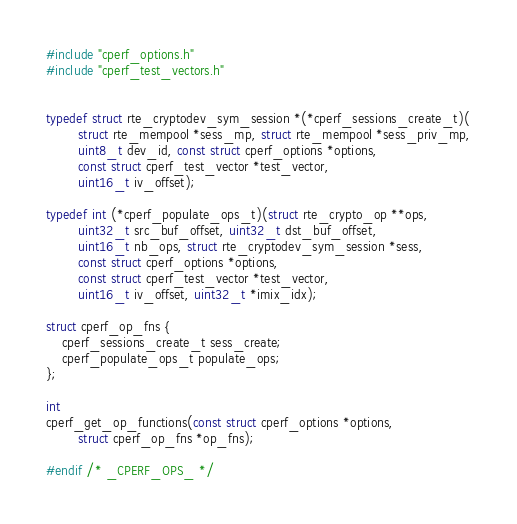<code> <loc_0><loc_0><loc_500><loc_500><_C_>#include "cperf_options.h"
#include "cperf_test_vectors.h"


typedef struct rte_cryptodev_sym_session *(*cperf_sessions_create_t)(
		struct rte_mempool *sess_mp, struct rte_mempool *sess_priv_mp,
		uint8_t dev_id, const struct cperf_options *options,
		const struct cperf_test_vector *test_vector,
		uint16_t iv_offset);

typedef int (*cperf_populate_ops_t)(struct rte_crypto_op **ops,
		uint32_t src_buf_offset, uint32_t dst_buf_offset,
		uint16_t nb_ops, struct rte_cryptodev_sym_session *sess,
		const struct cperf_options *options,
		const struct cperf_test_vector *test_vector,
		uint16_t iv_offset, uint32_t *imix_idx);

struct cperf_op_fns {
	cperf_sessions_create_t sess_create;
	cperf_populate_ops_t populate_ops;
};

int
cperf_get_op_functions(const struct cperf_options *options,
		struct cperf_op_fns *op_fns);

#endif /* _CPERF_OPS_ */
</code> 